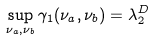<formula> <loc_0><loc_0><loc_500><loc_500>\sup _ { \nu _ { a } , \nu _ { b } } \gamma _ { 1 } ( \nu _ { a } , \nu _ { b } ) = \lambda _ { 2 } ^ { D }</formula> 